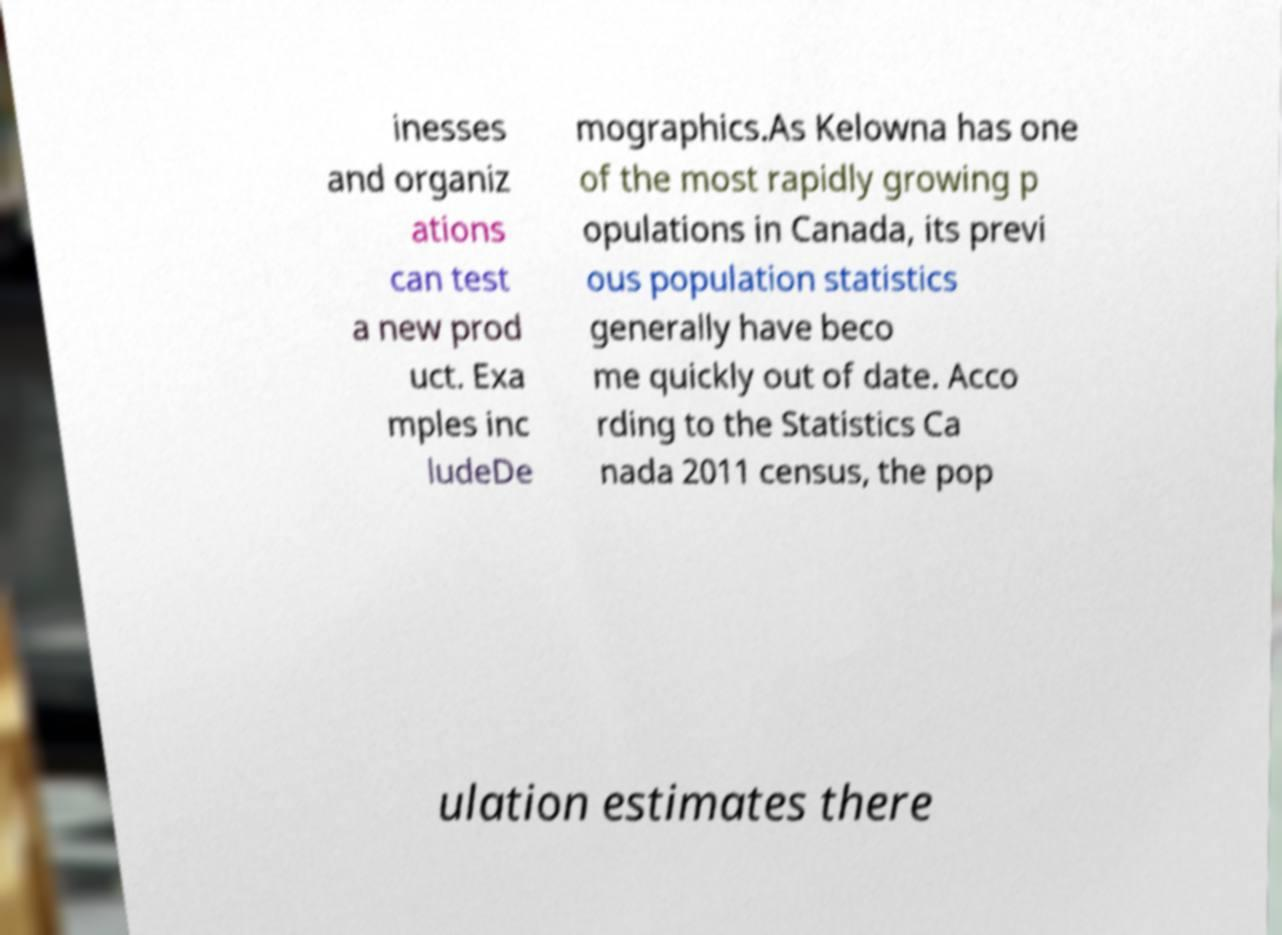There's text embedded in this image that I need extracted. Can you transcribe it verbatim? inesses and organiz ations can test a new prod uct. Exa mples inc ludeDe mographics.As Kelowna has one of the most rapidly growing p opulations in Canada, its previ ous population statistics generally have beco me quickly out of date. Acco rding to the Statistics Ca nada 2011 census, the pop ulation estimates there 